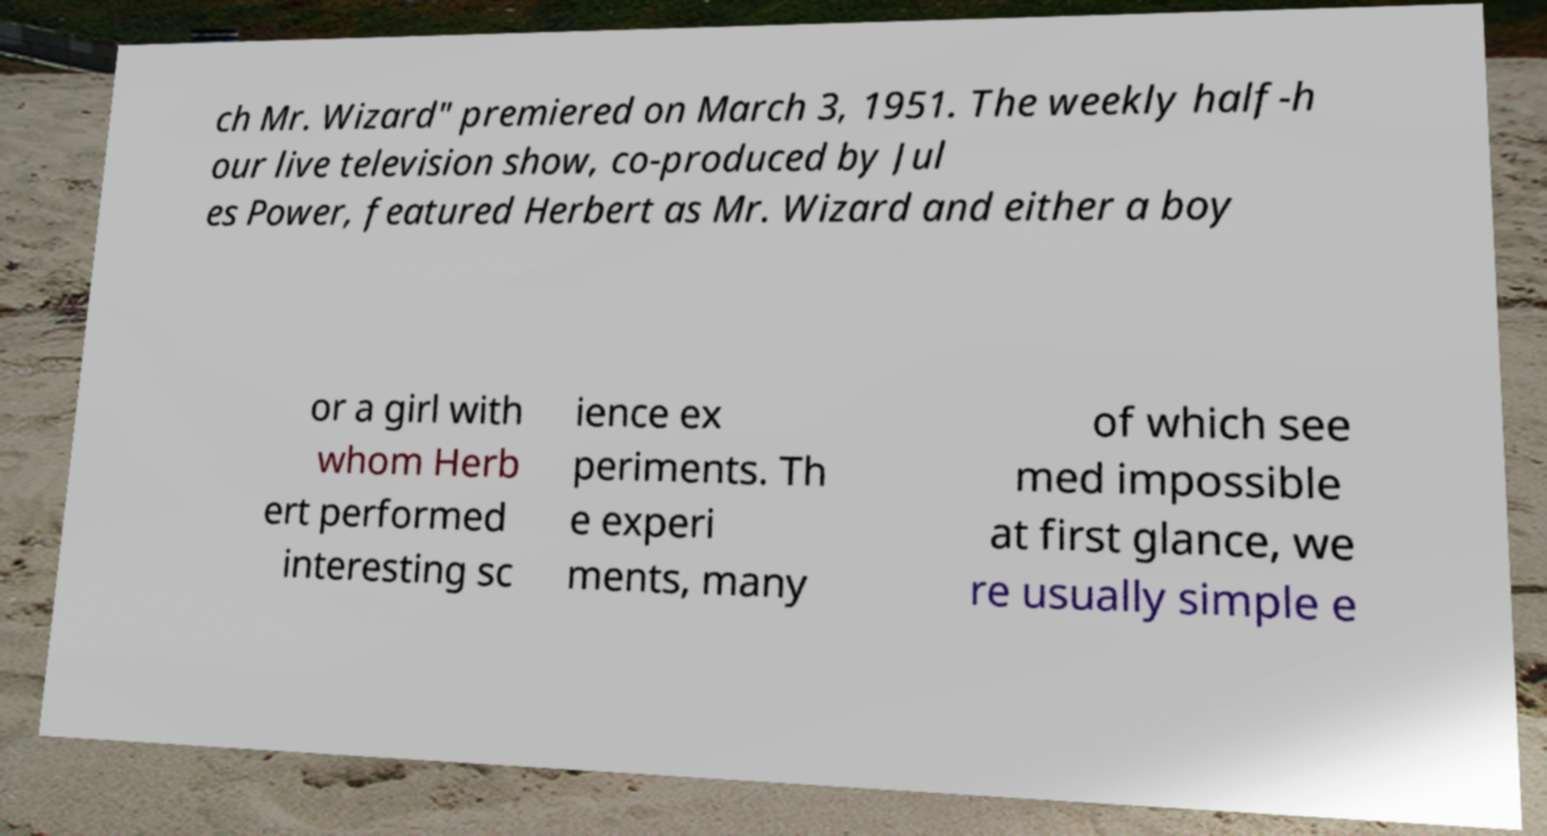Please read and relay the text visible in this image. What does it say? ch Mr. Wizard" premiered on March 3, 1951. The weekly half-h our live television show, co-produced by Jul es Power, featured Herbert as Mr. Wizard and either a boy or a girl with whom Herb ert performed interesting sc ience ex periments. Th e experi ments, many of which see med impossible at first glance, we re usually simple e 